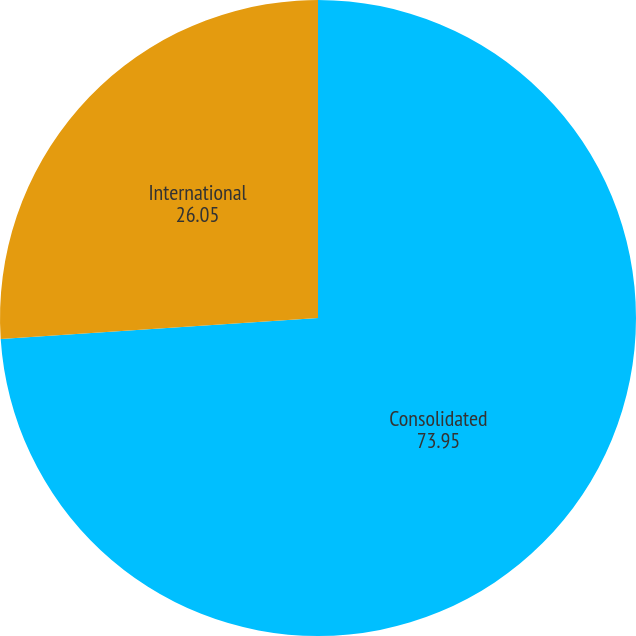Convert chart to OTSL. <chart><loc_0><loc_0><loc_500><loc_500><pie_chart><fcel>Consolidated<fcel>International<nl><fcel>73.95%<fcel>26.05%<nl></chart> 